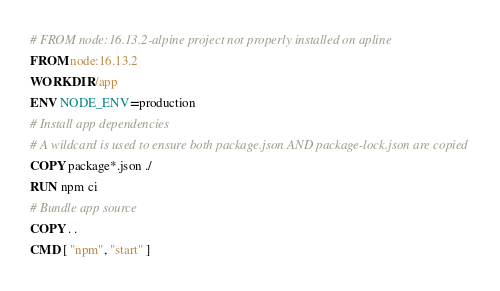Convert code to text. <code><loc_0><loc_0><loc_500><loc_500><_Dockerfile_># FROM node:16.13.2-alpine project not properly installed on apline
FROM node:16.13.2
WORKDIR /app
ENV NODE_ENV=production
# Install app dependencies
# A wildcard is used to ensure both package.json AND package-lock.json are copied
COPY package*.json ./
RUN npm ci
# Bundle app source
COPY . .
CMD [ "npm", "start" ]</code> 